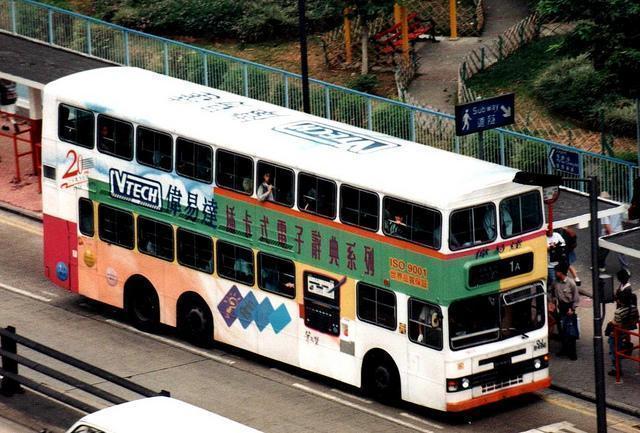On what side of the bus should they go if they want to take the metro?
Make your selection from the four choices given to correctly answer the question.
Options: Left, right, back, front. Left. 